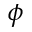Convert formula to latex. <formula><loc_0><loc_0><loc_500><loc_500>\phi</formula> 